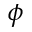Convert formula to latex. <formula><loc_0><loc_0><loc_500><loc_500>\phi</formula> 